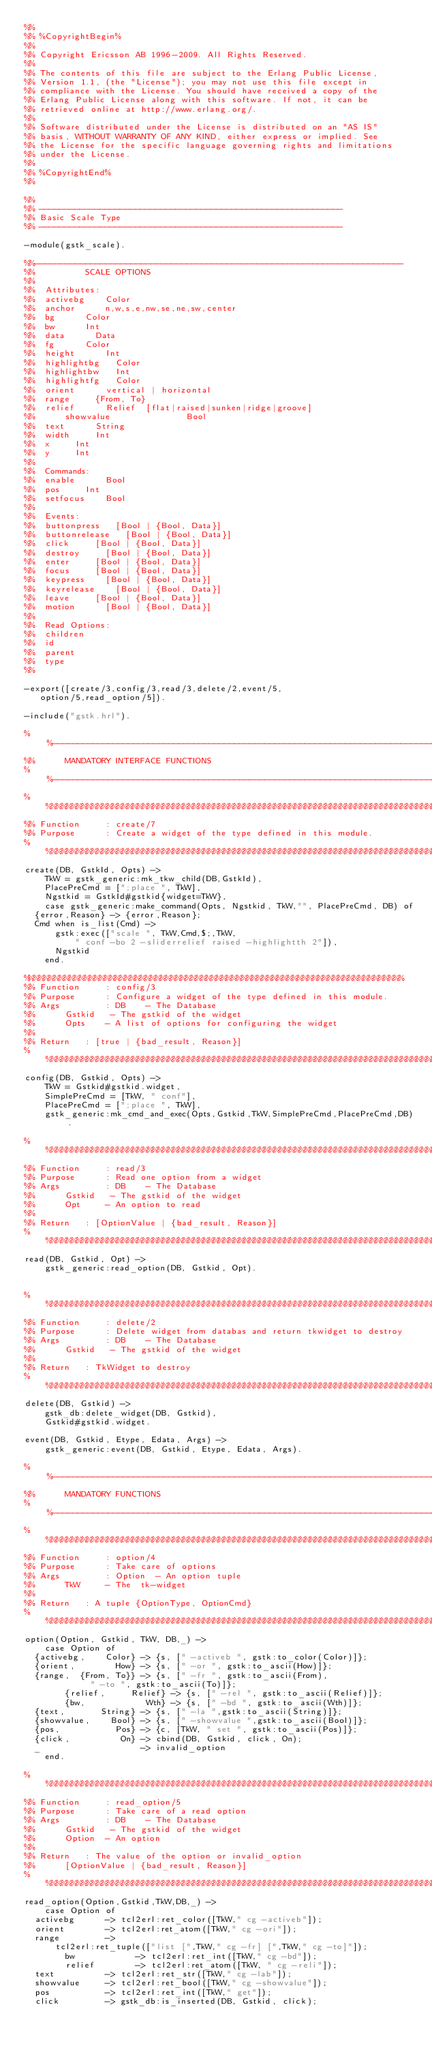Convert code to text. <code><loc_0><loc_0><loc_500><loc_500><_Erlang_>%%
%% %CopyrightBegin%
%% 
%% Copyright Ericsson AB 1996-2009. All Rights Reserved.
%% 
%% The contents of this file are subject to the Erlang Public License,
%% Version 1.1, (the "License"); you may not use this file except in
%% compliance with the License. You should have received a copy of the
%% Erlang Public License along with this software. If not, it can be
%% retrieved online at http://www.erlang.org/.
%% 
%% Software distributed under the License is distributed on an "AS IS"
%% basis, WITHOUT WARRANTY OF ANY KIND, either express or implied. See
%% the License for the specific language governing rights and limitations
%% under the License.
%% 
%% %CopyrightEnd%
%%

%%
%% ------------------------------------------------------------
%% Basic Scale Type
%% ------------------------------------------------------------

-module(gstk_scale).

%%-------------------------------------------------------------------------
%% 			    SCALE OPTIONS
%%
%%  Attributes:
%%	activebg		Color
%%	anchor			n,w,s,e,nw,se,ne,sw,center
%%	bg			Color
%%	bw			Int
%%	data			Data
%%	fg			Color
%%	height			Int
%%	highlightbg		Color
%%	highlightbw		Int
%%	highlightfg		Color
%%	orient			vertical | horizontal
%%	range			{From, To}
%%	relief			Relief	[flat|raised|sunken|ridge|groove]
%%      showvalue               Bool
%%	text			String
%%	width			Int
%%	x			Int
%%	y			Int
%%
%%  Commands:
%%	enable			Bool
%%	pos			Int
%%	setfocus		Bool
%%
%%  Events:
%%	buttonpress		[Bool | {Bool, Data}]
%%	buttonrelease		[Bool | {Bool, Data}]
%%	click			[Bool | {Bool, Data}]
%%	destroy			[Bool | {Bool, Data}]
%%	enter			[Bool | {Bool, Data}]
%%	focus			[Bool | {Bool, Data}]
%%	keypress		[Bool | {Bool, Data}]
%%	keyrelease		[Bool | {Bool, Data}]
%%	leave			[Bool | {Bool, Data}]
%%	motion			[Bool | {Bool, Data}]
%%
%%  Read Options:
%%	children
%%	id
%%	parent
%%	type
%%

-export([create/3,config/3,read/3,delete/2,event/5,
	 option/5,read_option/5]).

-include("gstk.hrl").

%%------------------------------------------------------------------------------
%%			MANDATORY INTERFACE FUNCTIONS
%%------------------------------------------------------------------------------
%%%%%%%%%%%%%%%%%%%%%%%%%%%%%%%%%%%%%%%%%%%%%%%%%%%%%%%%%%%%%%%%%%%%%%%%%%%%%%%%
%% Function   	: create/7
%% Purpose    	: Create a widget of the type defined in this module.
%%%%%%%%%%%%%%%%%%%%%%%%%%%%%%%%%%%%%%%%%%%%%%%%%%%%%%%%%%%%%%%%%%%%%%%%%%%%%%%%
create(DB, GstkId, Opts) ->
    TkW = gstk_generic:mk_tkw_child(DB,GstkId),
    PlacePreCmd = [";place ", TkW],
    Ngstkid = GstkId#gstkid{widget=TkW},
    case gstk_generic:make_command(Opts, Ngstkid, TkW,"", PlacePreCmd, DB) of
	{error,Reason} -> {error,Reason};
	Cmd when is_list(Cmd) ->
	    gstk:exec(["scale ", TkW,Cmd,$;,TkW,
		      " conf -bo 2 -sliderrelief raised -highlightth 2"]),
	    Ngstkid
    end.

%%%%%%%%%%%%%%%%%%%%%%%%%%%%%%%%%%%%%%%%%%%%%%%%%%%%%%%%%%%%%%%%%%%%%%%%%%%
%% Function   	: config/3
%% Purpose    	: Configure a widget of the type defined in this module.
%% Args        	: DB	  - The Database
%%		  Gstkid   - The gstkid of the widget
%%		  Opts    - A list of options for configuring the widget
%%
%% Return 	: [true | {bad_result, Reason}]
%%%%%%%%%%%%%%%%%%%%%%%%%%%%%%%%%%%%%%%%%%%%%%%%%%%%%%%%%%%%%%%%%%%%%%%%%%%%%%%
config(DB, Gstkid, Opts) ->
    TkW = Gstkid#gstkid.widget,
    SimplePreCmd = [TkW, " conf"],
    PlacePreCmd = [";place ", TkW],
    gstk_generic:mk_cmd_and_exec(Opts,Gstkid,TkW,SimplePreCmd,PlacePreCmd,DB).

%%%%%%%%%%%%%%%%%%%%%%%%%%%%%%%%%%%%%%%%%%%%%%%%%%%%%%%%%%%%%%%%%%%%%%%%%%%%%%%
%% Function   	: read/3
%% Purpose    	: Read one option from a widget
%% Args        	: DB	  - The Database
%%		  Gstkid   - The gstkid of the widget
%%		  Opt     - An option to read
%%
%% Return 	: [OptionValue | {bad_result, Reason}]
%%%%%%%%%%%%%%%%%%%%%%%%%%%%%%%%%%%%%%%%%%%%%%%%%%%%%%%%%%%%%%%%%%%%%%%%%%%%%%%
read(DB, Gstkid, Opt) ->
    gstk_generic:read_option(DB, Gstkid, Opt).


%%%%%%%%%%%%%%%%%%%%%%%%%%%%%%%%%%%%%%%%%%%%%%%%%%%%%%%%%%%%%%%%%%%%%%%%%%%%%%%
%% Function   	: delete/2
%% Purpose    	: Delete widget from databas and return tkwidget to destroy
%% Args        	: DB	  - The Database
%%		  Gstkid   - The gstkid of the widget
%%
%% Return 	: TkWidget to destroy
%%%%%%%%%%%%%%%%%%%%%%%%%%%%%%%%%%%%%%%%%%%%%%%%%%%%%%%%%%%%%%%%%%%%%%%%%%%%%%%
delete(DB, Gstkid) ->
    gstk_db:delete_widget(DB, Gstkid),
    Gstkid#gstkid.widget.

event(DB, Gstkid, Etype, Edata, Args) ->
    gstk_generic:event(DB, Gstkid, Etype, Edata, Args).

%%-----------------------------------------------------------------------------
%%			MANDATORY FUNCTIONS
%%-----------------------------------------------------------------------------
%%%%%%%%%%%%%%%%%%%%%%%%%%%%%%%%%%%%%%%%%%%%%%%%%%%%%%%%%%%%%%%%%%%%%%%%%%%%%%%
%% Function   	: option/4
%% Purpose    	: Take care of options
%% Args        	: Option  - An option tuple
%%		  TkW     - The  tk-widget
%%
%% Return 	: A tuple {OptionType, OptionCmd}
%%%%%%%%%%%%%%%%%%%%%%%%%%%%%%%%%%%%%%%%%%%%%%%%%%%%%%%%%%%%%%%%%%%%%%%%%%%%%%%
option(Option, Gstkid, TkW, DB,_) ->
    case Option of
	{activebg,    Color} -> {s, [" -activeb ", gstk:to_color(Color)]};
	{orient,        How} -> {s, [" -or ", gstk:to_ascii(How)]};
	{range,  {From, To}} -> {s, [" -fr ", gstk:to_ascii(From),
				     " -to ", gstk:to_ascii(To)]};
        {relief,     Relief} -> {s, [" -rel ", gstk:to_ascii(Relief)]};
        {bw,            Wth} -> {s, [" -bd ", gstk:to_ascii(Wth)]};
	{text,       String} -> {s, [" -la ",gstk:to_ascii(String)]};
	{showvalue,    Bool} -> {s, [" -showvalue ",gstk:to_ascii(Bool)]};
	{pos,           Pos} -> {c, [TkW, " set ", gstk:to_ascii(Pos)]};
	{click,          On} -> cbind(DB, Gstkid, click, On);
	_                    -> invalid_option
    end.

%%%%%%%%%%%%%%%%%%%%%%%%%%%%%%%%%%%%%%%%%%%%%%%%%%%%%%%%%%%%%%%%%%%%%%%%%%%%%%%%
%% Function   	: read_option/5
%% Purpose    	: Take care of a read option
%% Args        	: DB	  - The Database
%%		  Gstkid   - The gstkid of the widget
%%		  Option  - An option
%%
%% Return 	: The value of the option or invalid_option
%%		  [OptionValue | {bad_result, Reason}]
%%%%%%%%%%%%%%%%%%%%%%%%%%%%%%%%%%%%%%%%%%%%%%%%%%%%%%%%%%%%%%%%%%%%%%%%%%%%%%%%
read_option(Option,Gstkid,TkW,DB,_) -> 
    case Option of
	activebg      -> tcl2erl:ret_color([TkW," cg -activeb"]);
	orient        -> tcl2erl:ret_atom([TkW," cg -ori"]);
	range         ->
	    tcl2erl:ret_tuple(["list [",TkW," cg -fr] [",TkW," cg -to]"]);
        bw            -> tcl2erl:ret_int([TkW," cg -bd"]);
        relief        -> tcl2erl:ret_atom([TkW, " cg -reli"]);
	text          -> tcl2erl:ret_str([TkW," cg -lab"]);
	showvalue     -> tcl2erl:ret_bool([TkW," cg -showvalue"]);
	pos           -> tcl2erl:ret_int([TkW," get"]);
	click         -> gstk_db:is_inserted(DB, Gstkid, click);</code> 